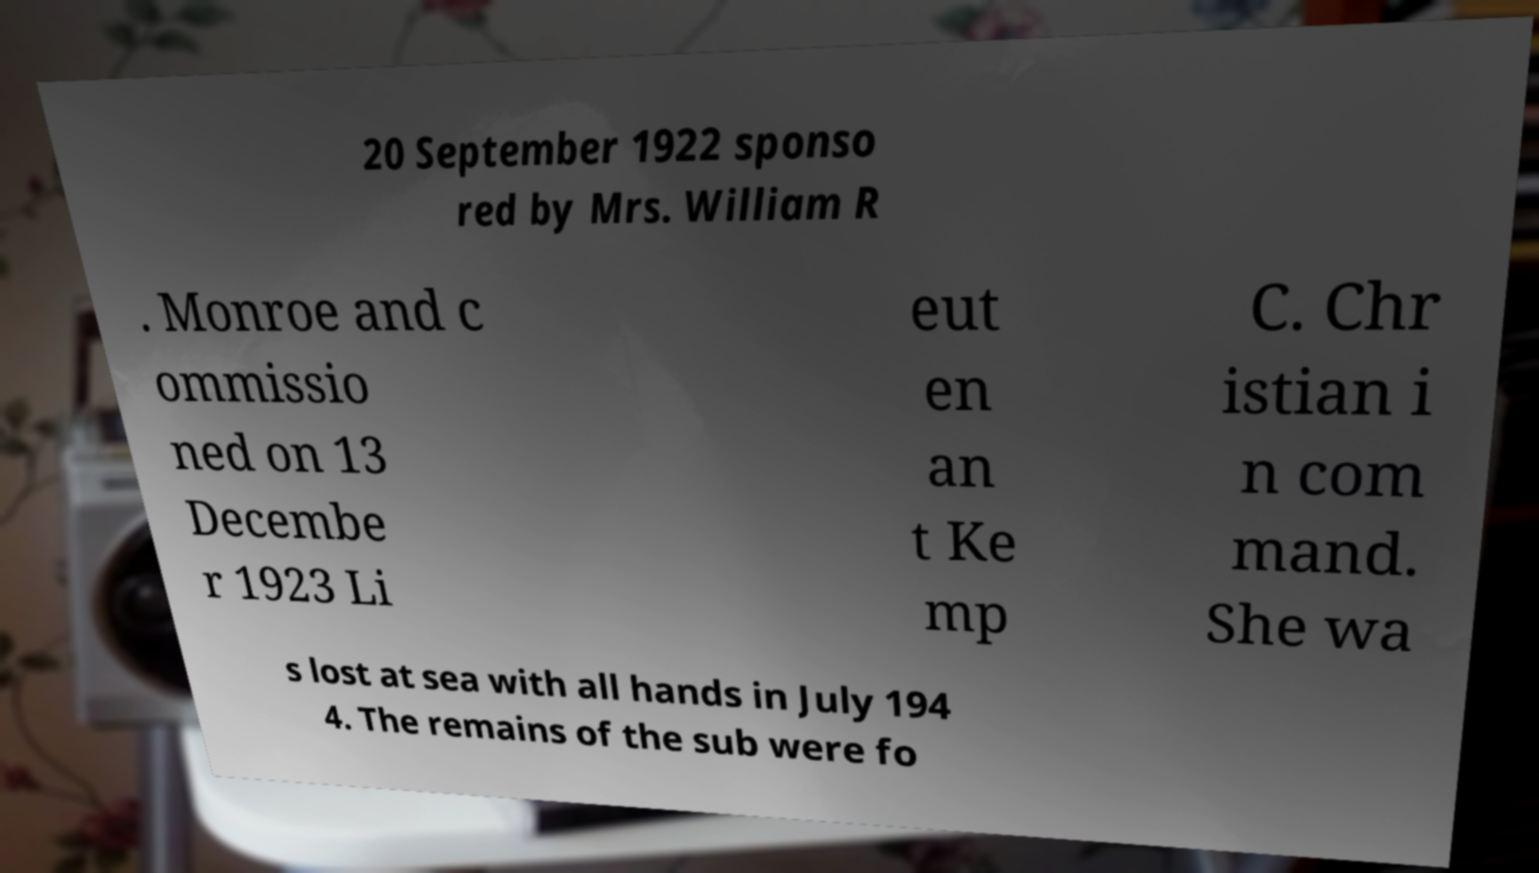Could you extract and type out the text from this image? 20 September 1922 sponso red by Mrs. William R . Monroe and c ommissio ned on 13 Decembe r 1923 Li eut en an t Ke mp C. Chr istian i n com mand. She wa s lost at sea with all hands in July 194 4. The remains of the sub were fo 